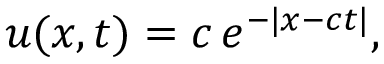Convert formula to latex. <formula><loc_0><loc_0><loc_500><loc_500>u ( x , t ) = c \, e ^ { - | x - c t | } ,</formula> 